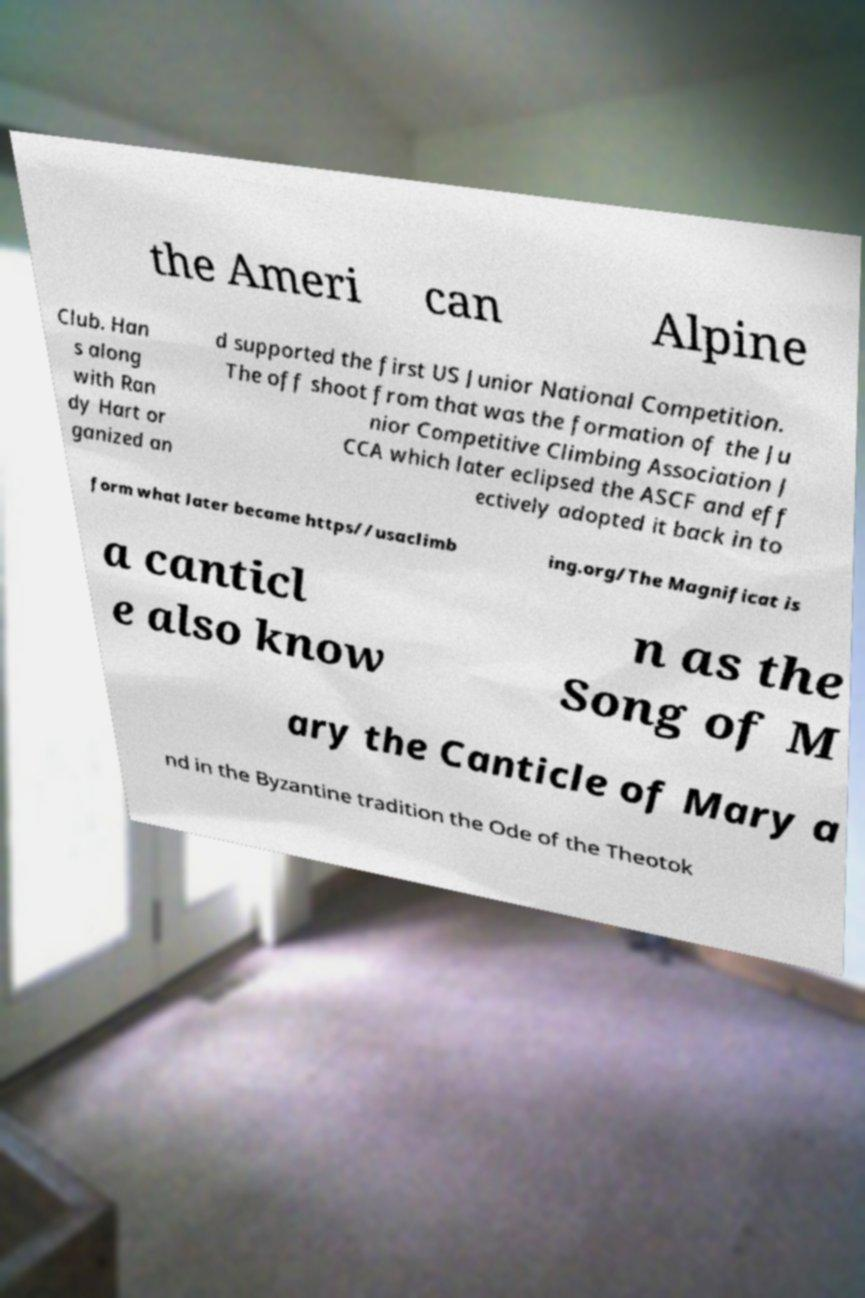What messages or text are displayed in this image? I need them in a readable, typed format. the Ameri can Alpine Club. Han s along with Ran dy Hart or ganized an d supported the first US Junior National Competition. The off shoot from that was the formation of the Ju nior Competitive Climbing Association J CCA which later eclipsed the ASCF and eff ectively adopted it back in to form what later became https//usaclimb ing.org/The Magnificat is a canticl e also know n as the Song of M ary the Canticle of Mary a nd in the Byzantine tradition the Ode of the Theotok 